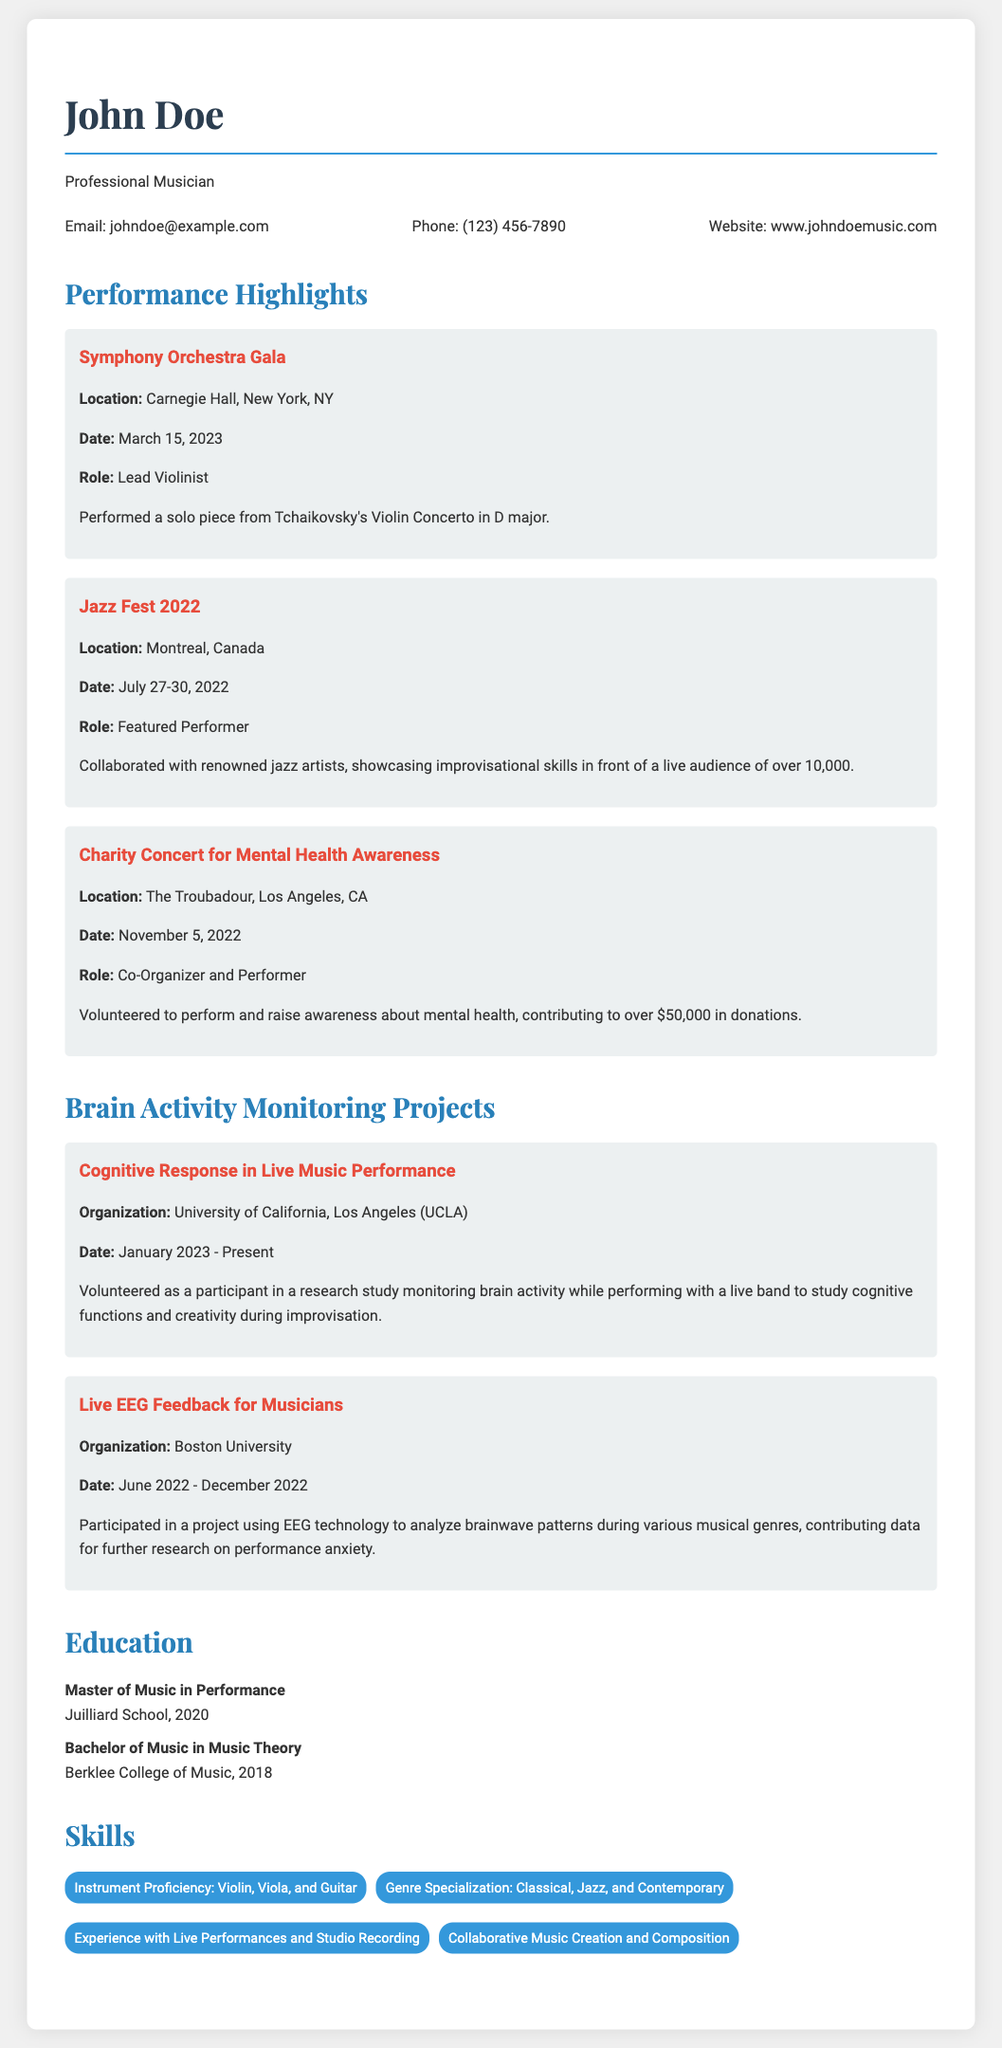What role did John Doe have at the Symphony Orchestra Gala? The document states that John Doe's role was Lead Violinist at the Symphony Orchestra Gala.
Answer: Lead Violinist When was the Jazz Fest held? The document provides the dates for the Jazz Fest as July 27-30, 2022.
Answer: July 27-30, 2022 How much money was raised during the Charity Concert for Mental Health Awareness? According to the document, over $50,000 was raised during the Charity Concert.
Answer: Over $50,000 What is the organization associated with the cognitive response research project? The document mentions the University of California, Los Angeles (UCLA) as the organization for the brain activity monitoring project.
Answer: University of California, Los Angeles (UCLA) What degree did John Doe earn from the Juilliard School? The document states that John Doe earned a Master of Music in Performance from the Juilliard School.
Answer: Master of Music in Performance How long did the Live EEG Feedback for Musicians project last? The document indicates that the project lasted from June 2022 to December 2022, which is a span of 6 months.
Answer: 6 months What genre specializations does John Doe have? The document lists Classical, Jazz, and Contemporary as John Doe’s genre specializations.
Answer: Classical, Jazz, and Contemporary What was John Doe's role in the Charity Concert? According to the document, John Doe was a Co-Organizer and Performer at the Charity Concert.
Answer: Co-Organizer and Performer 